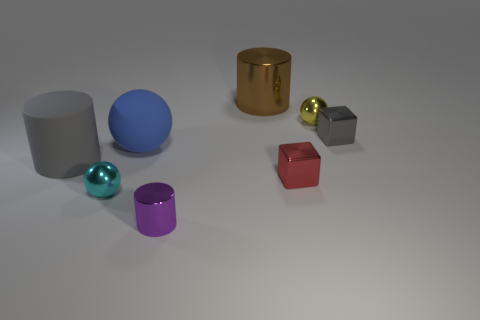Are there any small metallic balls that have the same color as the tiny metal cylinder? Upon careful examination of the image, there are no small metallic balls that share an exact color match with the tiny metal cylinder, which appears to be gold or brass in hue. All the balls present exhibit distinct colors of their own. 